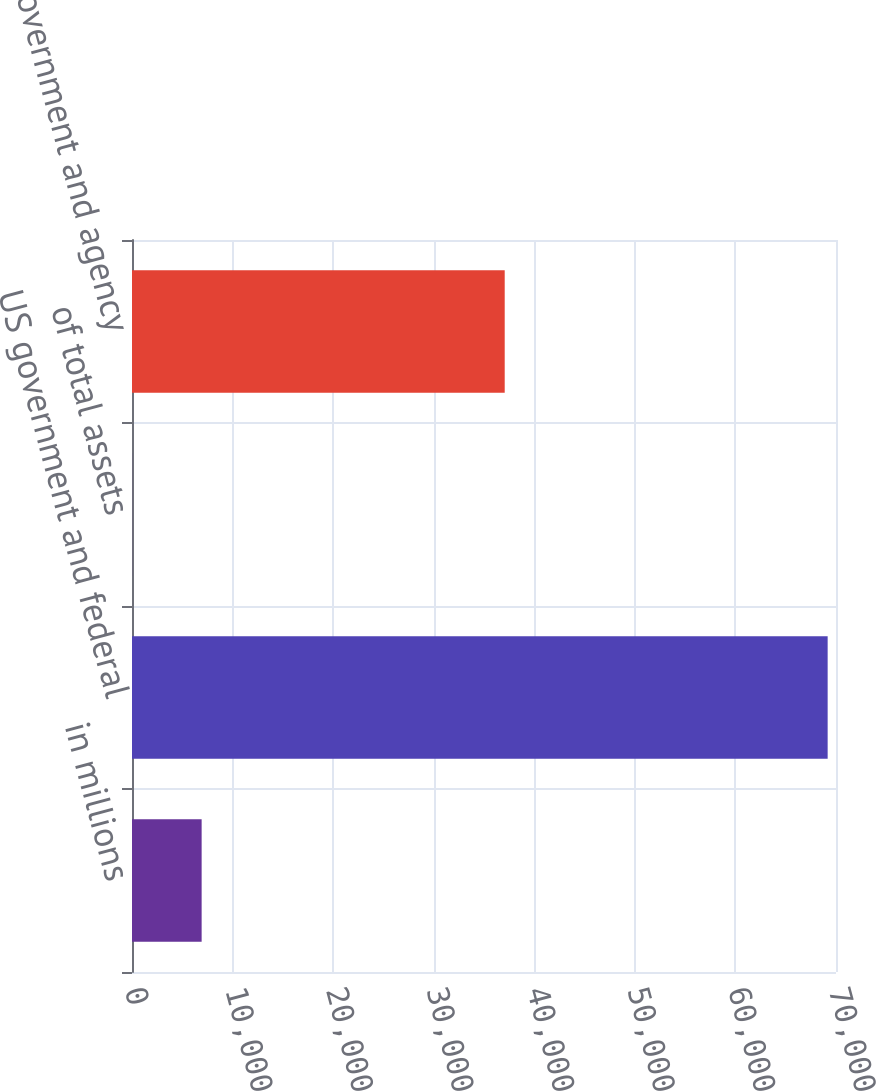Convert chart. <chart><loc_0><loc_0><loc_500><loc_500><bar_chart><fcel>in millions<fcel>US government and federal<fcel>of total assets<fcel>Non-US government and agency<nl><fcel>6924.29<fcel>69170<fcel>8.1<fcel>37059<nl></chart> 